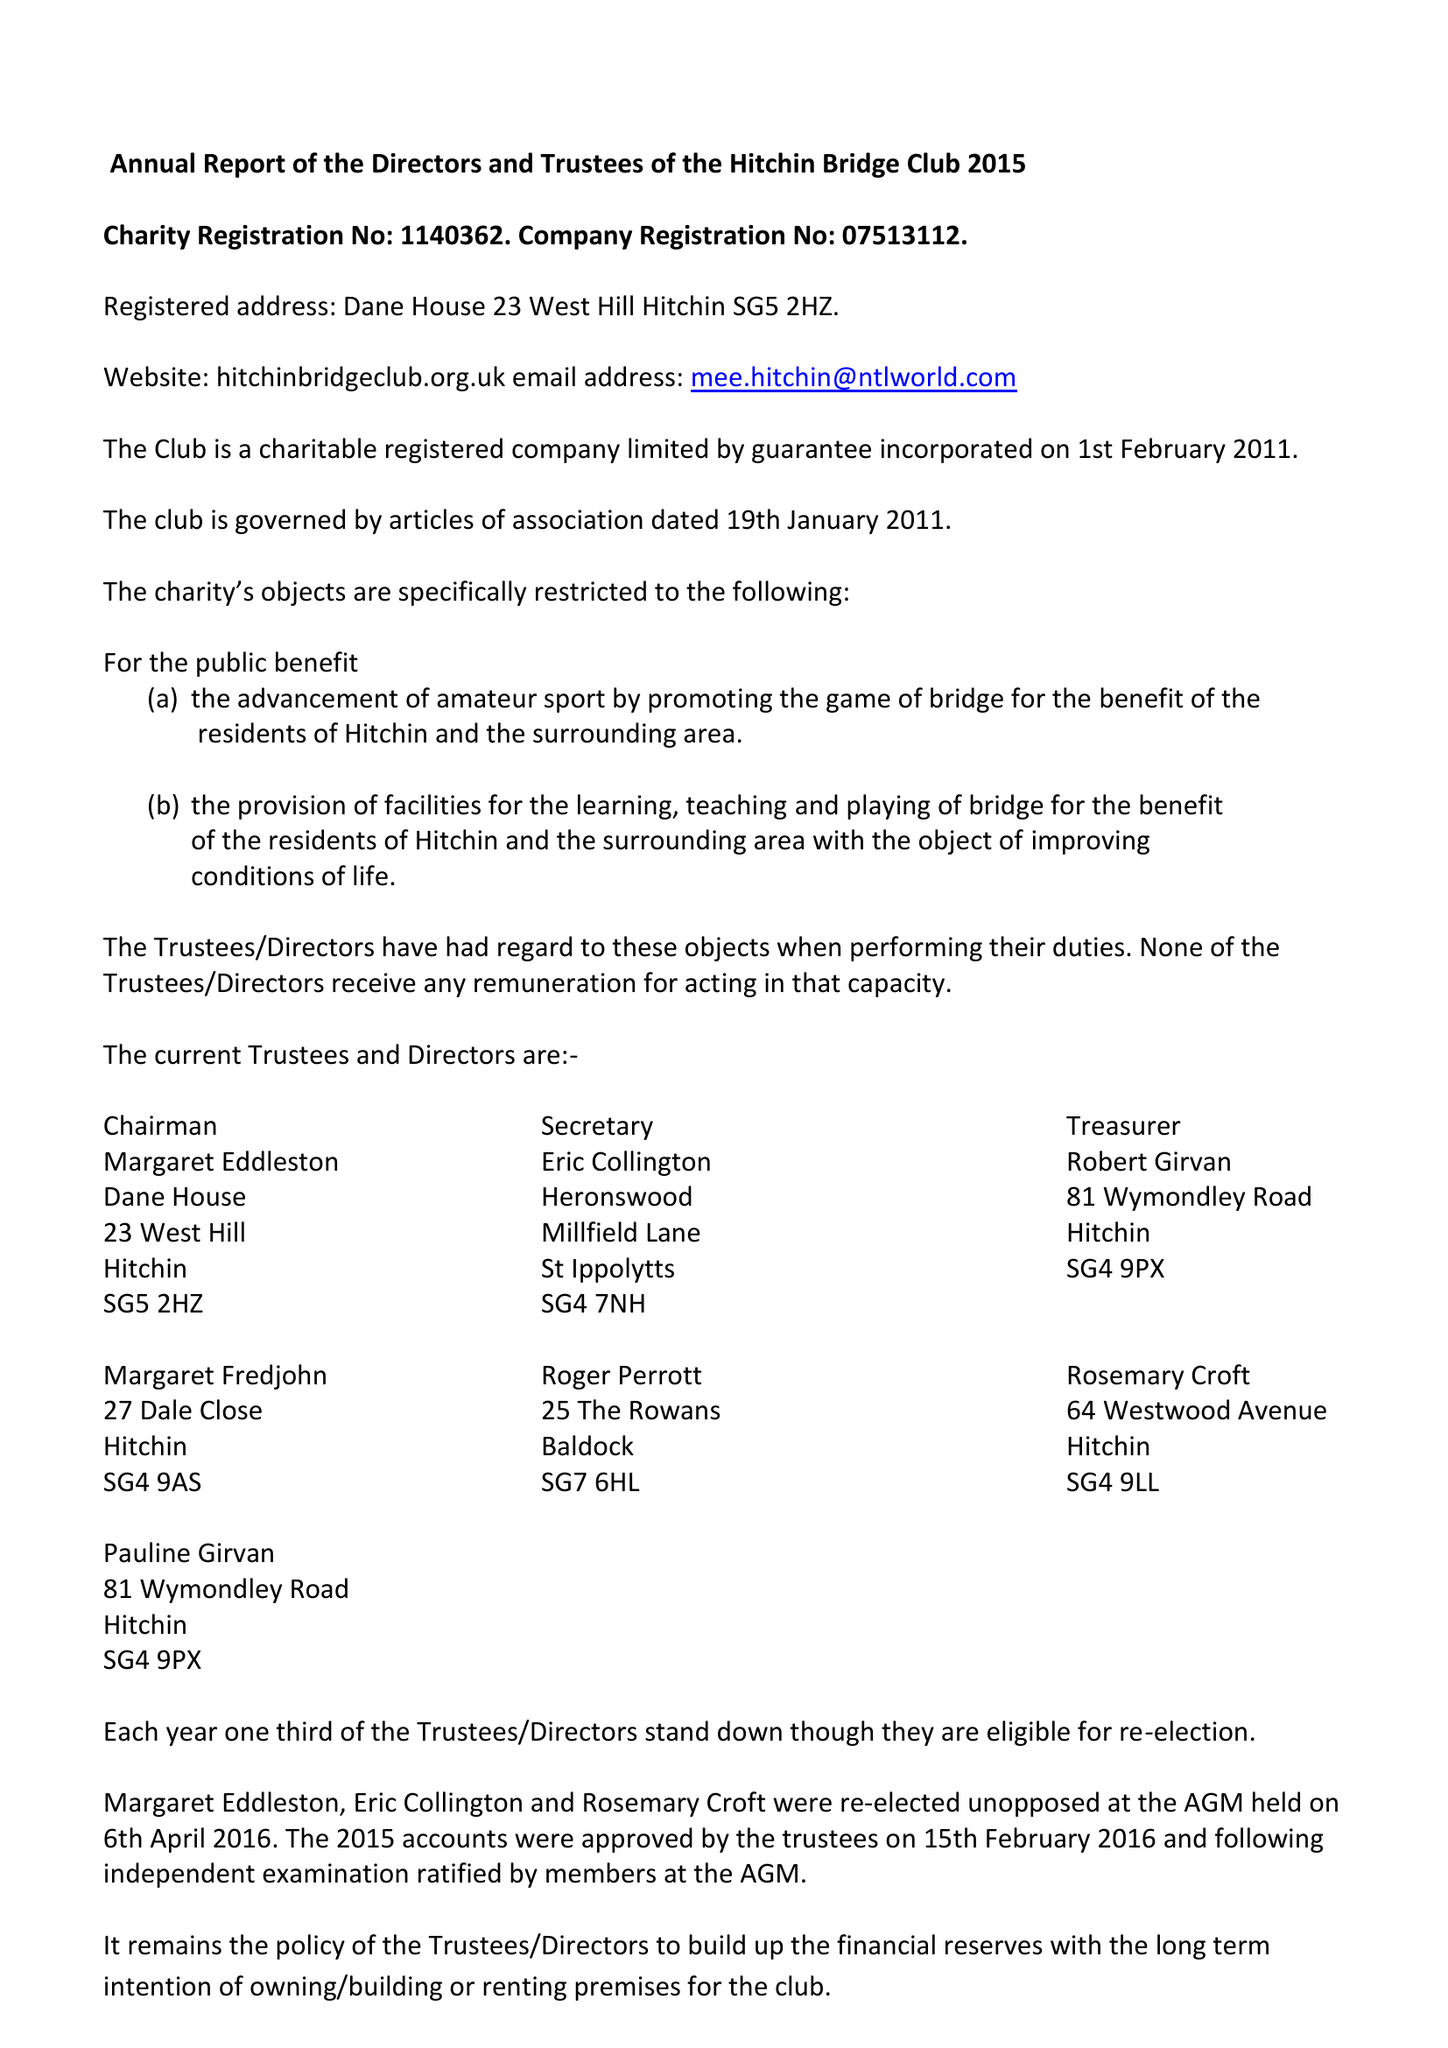What is the value for the address__post_town?
Answer the question using a single word or phrase. HITCHIN 